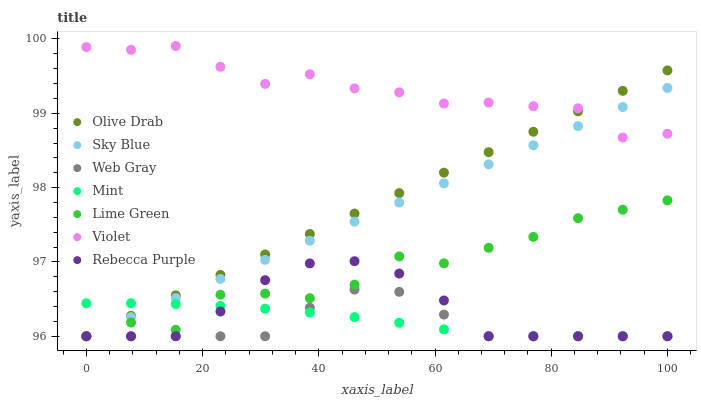Does Web Gray have the minimum area under the curve?
Answer yes or no. Yes. Does Violet have the maximum area under the curve?
Answer yes or no. Yes. Does Mint have the minimum area under the curve?
Answer yes or no. No. Does Mint have the maximum area under the curve?
Answer yes or no. No. Is Sky Blue the smoothest?
Answer yes or no. Yes. Is Lime Green the roughest?
Answer yes or no. Yes. Is Mint the smoothest?
Answer yes or no. No. Is Mint the roughest?
Answer yes or no. No. Does Web Gray have the lowest value?
Answer yes or no. Yes. Does Violet have the lowest value?
Answer yes or no. No. Does Violet have the highest value?
Answer yes or no. Yes. Does Rebecca Purple have the highest value?
Answer yes or no. No. Is Rebecca Purple less than Violet?
Answer yes or no. Yes. Is Violet greater than Mint?
Answer yes or no. Yes. Does Sky Blue intersect Rebecca Purple?
Answer yes or no. Yes. Is Sky Blue less than Rebecca Purple?
Answer yes or no. No. Is Sky Blue greater than Rebecca Purple?
Answer yes or no. No. Does Rebecca Purple intersect Violet?
Answer yes or no. No. 